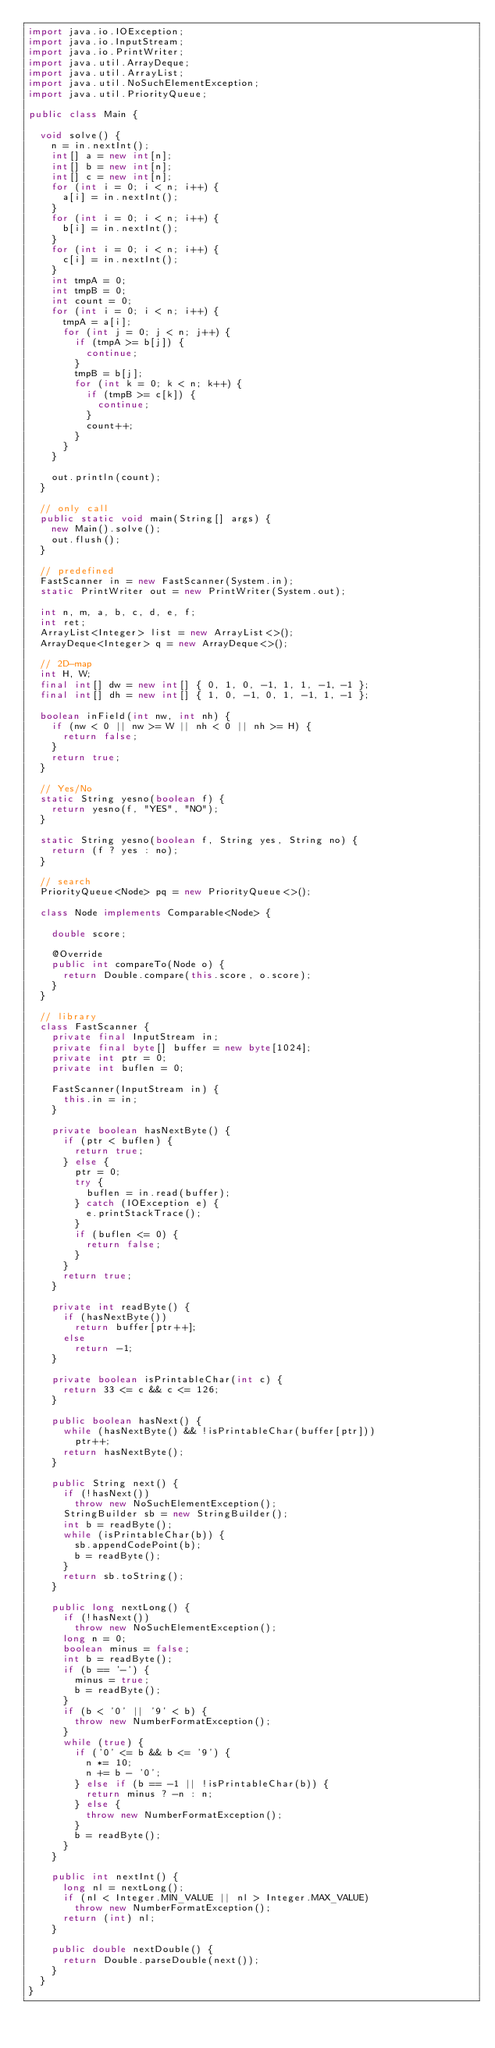<code> <loc_0><loc_0><loc_500><loc_500><_Java_>import java.io.IOException;
import java.io.InputStream;
import java.io.PrintWriter;
import java.util.ArrayDeque;
import java.util.ArrayList;
import java.util.NoSuchElementException;
import java.util.PriorityQueue;

public class Main {

	void solve() {
		n = in.nextInt();
		int[] a = new int[n];
		int[] b = new int[n];
		int[] c = new int[n];
		for (int i = 0; i < n; i++) {
			a[i] = in.nextInt();
		}
		for (int i = 0; i < n; i++) {
			b[i] = in.nextInt();
		}
		for (int i = 0; i < n; i++) {
			c[i] = in.nextInt();
		}
		int tmpA = 0;
		int tmpB = 0;
		int count = 0;
		for (int i = 0; i < n; i++) {
			tmpA = a[i];
			for (int j = 0; j < n; j++) {
				if (tmpA >= b[j]) {
					continue;
				}
				tmpB = b[j];
				for (int k = 0; k < n; k++) {
					if (tmpB >= c[k]) {
						continue;
					}
					count++;
				}
			}
		}

		out.println(count);
	}

	// only call
	public static void main(String[] args) {
		new Main().solve();
		out.flush();
	}

	// predefined
	FastScanner in = new FastScanner(System.in);
	static PrintWriter out = new PrintWriter(System.out);

	int n, m, a, b, c, d, e, f;
	int ret;
	ArrayList<Integer> list = new ArrayList<>();
	ArrayDeque<Integer> q = new ArrayDeque<>();

	// 2D-map
	int H, W;
	final int[] dw = new int[] { 0, 1, 0, -1, 1, 1, -1, -1 };
	final int[] dh = new int[] { 1, 0, -1, 0, 1, -1, 1, -1 };

	boolean inField(int nw, int nh) {
		if (nw < 0 || nw >= W || nh < 0 || nh >= H) {
			return false;
		}
		return true;
	}

	// Yes/No
	static String yesno(boolean f) {
		return yesno(f, "YES", "NO");
	}

	static String yesno(boolean f, String yes, String no) {
		return (f ? yes : no);
	}

	// search
	PriorityQueue<Node> pq = new PriorityQueue<>();

	class Node implements Comparable<Node> {

		double score;

		@Override
		public int compareTo(Node o) {
			return Double.compare(this.score, o.score);
		}
	}

	// library
	class FastScanner {
		private final InputStream in;
		private final byte[] buffer = new byte[1024];
		private int ptr = 0;
		private int buflen = 0;

		FastScanner(InputStream in) {
			this.in = in;
		}

		private boolean hasNextByte() {
			if (ptr < buflen) {
				return true;
			} else {
				ptr = 0;
				try {
					buflen = in.read(buffer);
				} catch (IOException e) {
					e.printStackTrace();
				}
				if (buflen <= 0) {
					return false;
				}
			}
			return true;
		}

		private int readByte() {
			if (hasNextByte())
				return buffer[ptr++];
			else
				return -1;
		}

		private boolean isPrintableChar(int c) {
			return 33 <= c && c <= 126;
		}

		public boolean hasNext() {
			while (hasNextByte() && !isPrintableChar(buffer[ptr]))
				ptr++;
			return hasNextByte();
		}

		public String next() {
			if (!hasNext())
				throw new NoSuchElementException();
			StringBuilder sb = new StringBuilder();
			int b = readByte();
			while (isPrintableChar(b)) {
				sb.appendCodePoint(b);
				b = readByte();
			}
			return sb.toString();
		}

		public long nextLong() {
			if (!hasNext())
				throw new NoSuchElementException();
			long n = 0;
			boolean minus = false;
			int b = readByte();
			if (b == '-') {
				minus = true;
				b = readByte();
			}
			if (b < '0' || '9' < b) {
				throw new NumberFormatException();
			}
			while (true) {
				if ('0' <= b && b <= '9') {
					n *= 10;
					n += b - '0';
				} else if (b == -1 || !isPrintableChar(b)) {
					return minus ? -n : n;
				} else {
					throw new NumberFormatException();
				}
				b = readByte();
			}
		}

		public int nextInt() {
			long nl = nextLong();
			if (nl < Integer.MIN_VALUE || nl > Integer.MAX_VALUE)
				throw new NumberFormatException();
			return (int) nl;
		}

		public double nextDouble() {
			return Double.parseDouble(next());
		}
	}
}</code> 